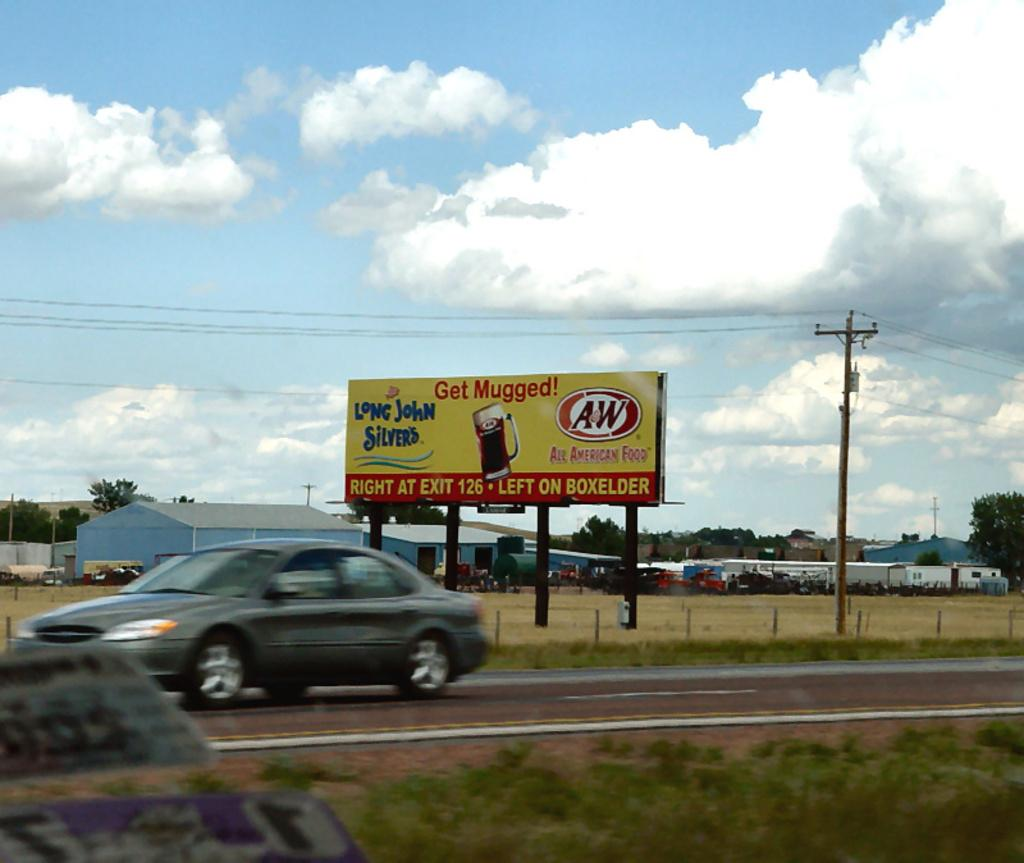Provide a one-sentence caption for the provided image. A bill board on the side of the road is for Long John Silvers restaurant. 